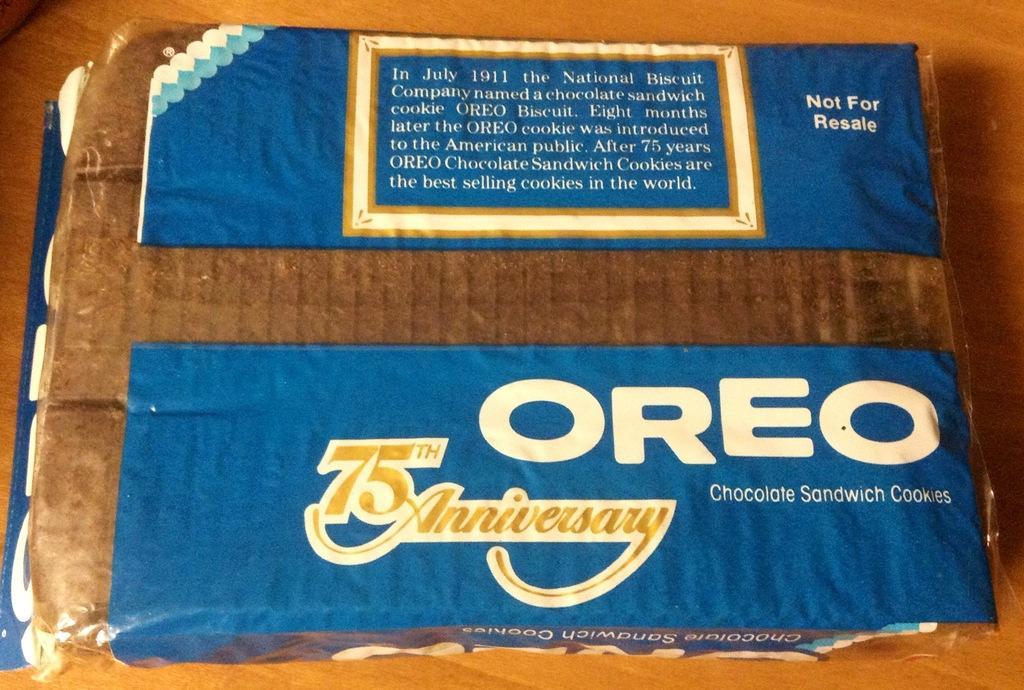Please provide a concise description of this image. In this image, we can see it looks like a biscuit packet with some text on it. 